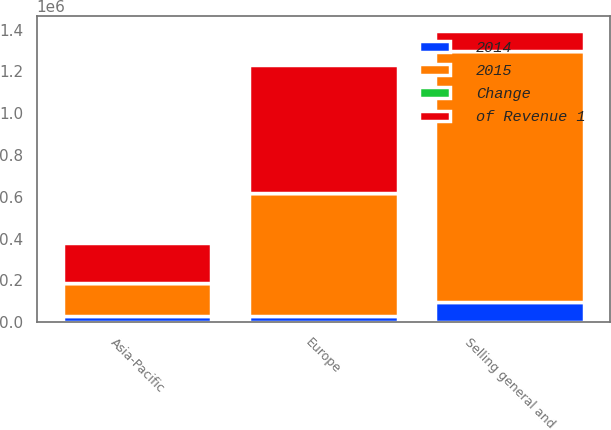<chart> <loc_0><loc_0><loc_500><loc_500><stacked_bar_chart><ecel><fcel>Europe<fcel>Asia-Pacific<fcel>Selling general and<nl><fcel>of Revenue 1<fcel>615966<fcel>188862<fcel>98502<nl><fcel>Change<fcel>22.2<fcel>6.8<fcel>46.7<nl><fcel>2015<fcel>587463<fcel>157781<fcel>1.19651e+06<nl><fcel>2014<fcel>28503<fcel>31081<fcel>98502<nl></chart> 